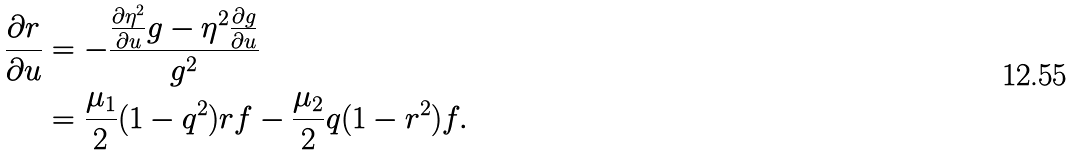<formula> <loc_0><loc_0><loc_500><loc_500>\frac { \partial r } { \partial u } & = - \frac { \frac { \partial \eta ^ { 2 } } { \partial u } g - \eta ^ { 2 } \frac { \partial g } { \partial u } } { g ^ { 2 } } \\ & = \frac { \mu _ { 1 } } { 2 } ( 1 - q ^ { 2 } ) r f - \frac { \mu _ { 2 } } { 2 } q ( 1 - r ^ { 2 } ) f .</formula> 